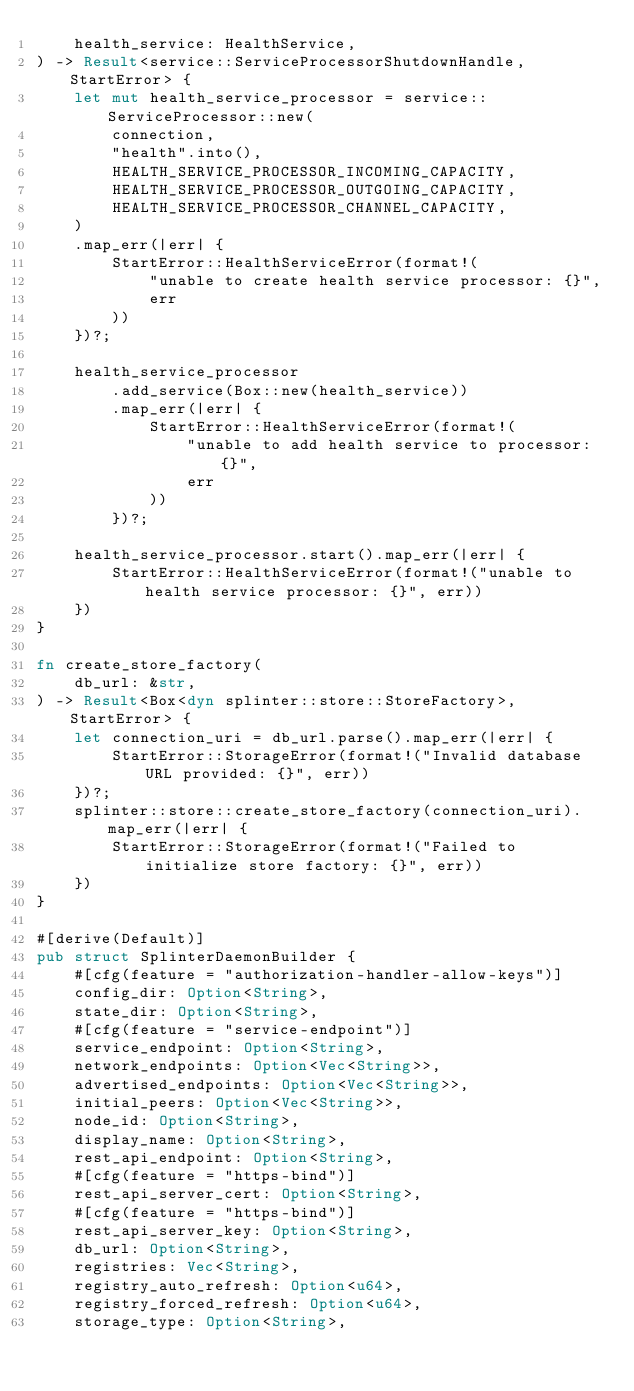Convert code to text. <code><loc_0><loc_0><loc_500><loc_500><_Rust_>    health_service: HealthService,
) -> Result<service::ServiceProcessorShutdownHandle, StartError> {
    let mut health_service_processor = service::ServiceProcessor::new(
        connection,
        "health".into(),
        HEALTH_SERVICE_PROCESSOR_INCOMING_CAPACITY,
        HEALTH_SERVICE_PROCESSOR_OUTGOING_CAPACITY,
        HEALTH_SERVICE_PROCESSOR_CHANNEL_CAPACITY,
    )
    .map_err(|err| {
        StartError::HealthServiceError(format!(
            "unable to create health service processor: {}",
            err
        ))
    })?;

    health_service_processor
        .add_service(Box::new(health_service))
        .map_err(|err| {
            StartError::HealthServiceError(format!(
                "unable to add health service to processor: {}",
                err
            ))
        })?;

    health_service_processor.start().map_err(|err| {
        StartError::HealthServiceError(format!("unable to health service processor: {}", err))
    })
}

fn create_store_factory(
    db_url: &str,
) -> Result<Box<dyn splinter::store::StoreFactory>, StartError> {
    let connection_uri = db_url.parse().map_err(|err| {
        StartError::StorageError(format!("Invalid database URL provided: {}", err))
    })?;
    splinter::store::create_store_factory(connection_uri).map_err(|err| {
        StartError::StorageError(format!("Failed to initialize store factory: {}", err))
    })
}

#[derive(Default)]
pub struct SplinterDaemonBuilder {
    #[cfg(feature = "authorization-handler-allow-keys")]
    config_dir: Option<String>,
    state_dir: Option<String>,
    #[cfg(feature = "service-endpoint")]
    service_endpoint: Option<String>,
    network_endpoints: Option<Vec<String>>,
    advertised_endpoints: Option<Vec<String>>,
    initial_peers: Option<Vec<String>>,
    node_id: Option<String>,
    display_name: Option<String>,
    rest_api_endpoint: Option<String>,
    #[cfg(feature = "https-bind")]
    rest_api_server_cert: Option<String>,
    #[cfg(feature = "https-bind")]
    rest_api_server_key: Option<String>,
    db_url: Option<String>,
    registries: Vec<String>,
    registry_auto_refresh: Option<u64>,
    registry_forced_refresh: Option<u64>,
    storage_type: Option<String>,</code> 